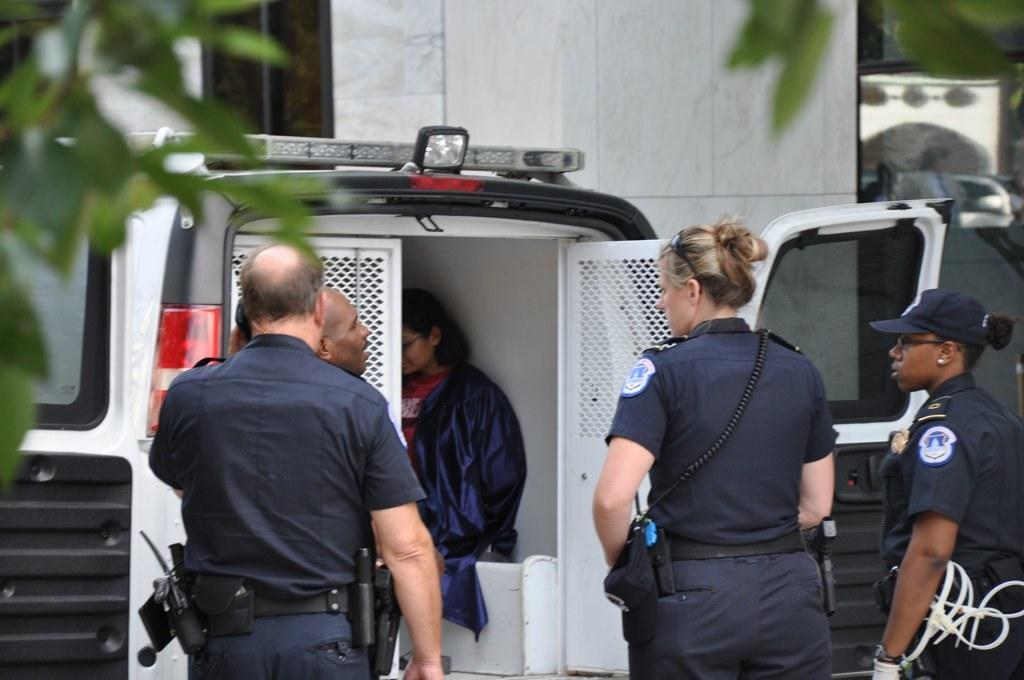How many people are present in the image? There are five persons in the image. What is located in the front of the image? There is a van in the front of the image. What can be seen in the background of the image? There is a wall in the background of the image. What type of vegetation is visible at the left top of the image? Leaves are visible at the left top of the image. What type of vase can be seen on the wall in the image? There is no vase present on the wall in the image. How does the fog affect the visibility of the persons in the image? There is no fog present in the image, so it does not affect the visibility of the persons. 